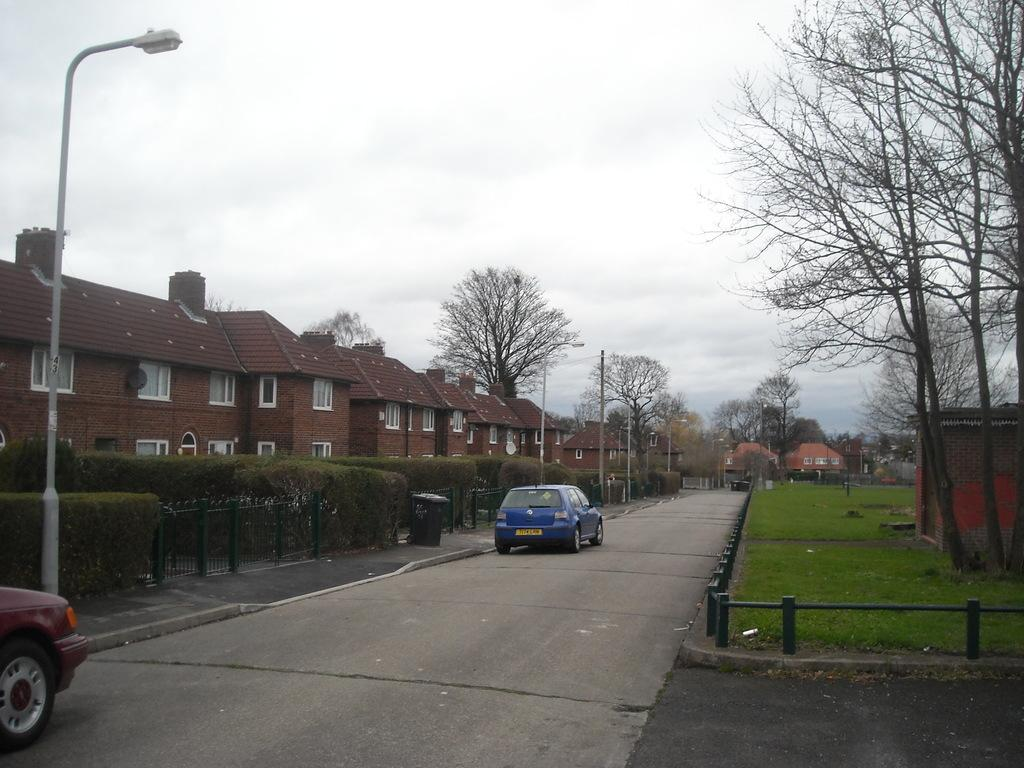What types of objects can be seen in the image? There are vehicles, poles, trees, buildings, and street lights in the image. What type of ground surface is visible in the image? There is grass visible in the image. What part of the natural environment is visible in the image? The sky is visible in the image. What type of shoe can be seen hanging from the pole in the image? There is no shoe present in the image; only vehicles, poles, trees, buildings, grass, and street lights are visible. 